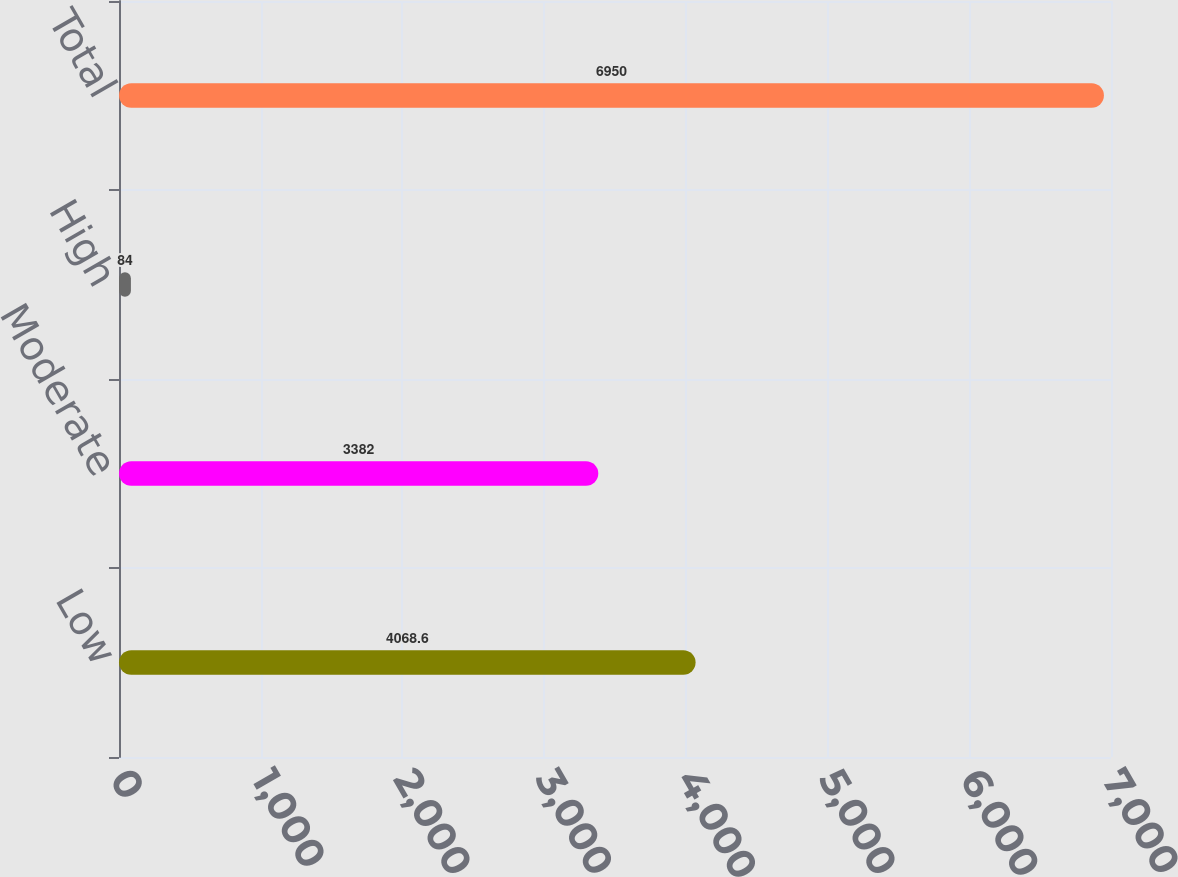Convert chart to OTSL. <chart><loc_0><loc_0><loc_500><loc_500><bar_chart><fcel>Low<fcel>Moderate<fcel>High<fcel>Total<nl><fcel>4068.6<fcel>3382<fcel>84<fcel>6950<nl></chart> 